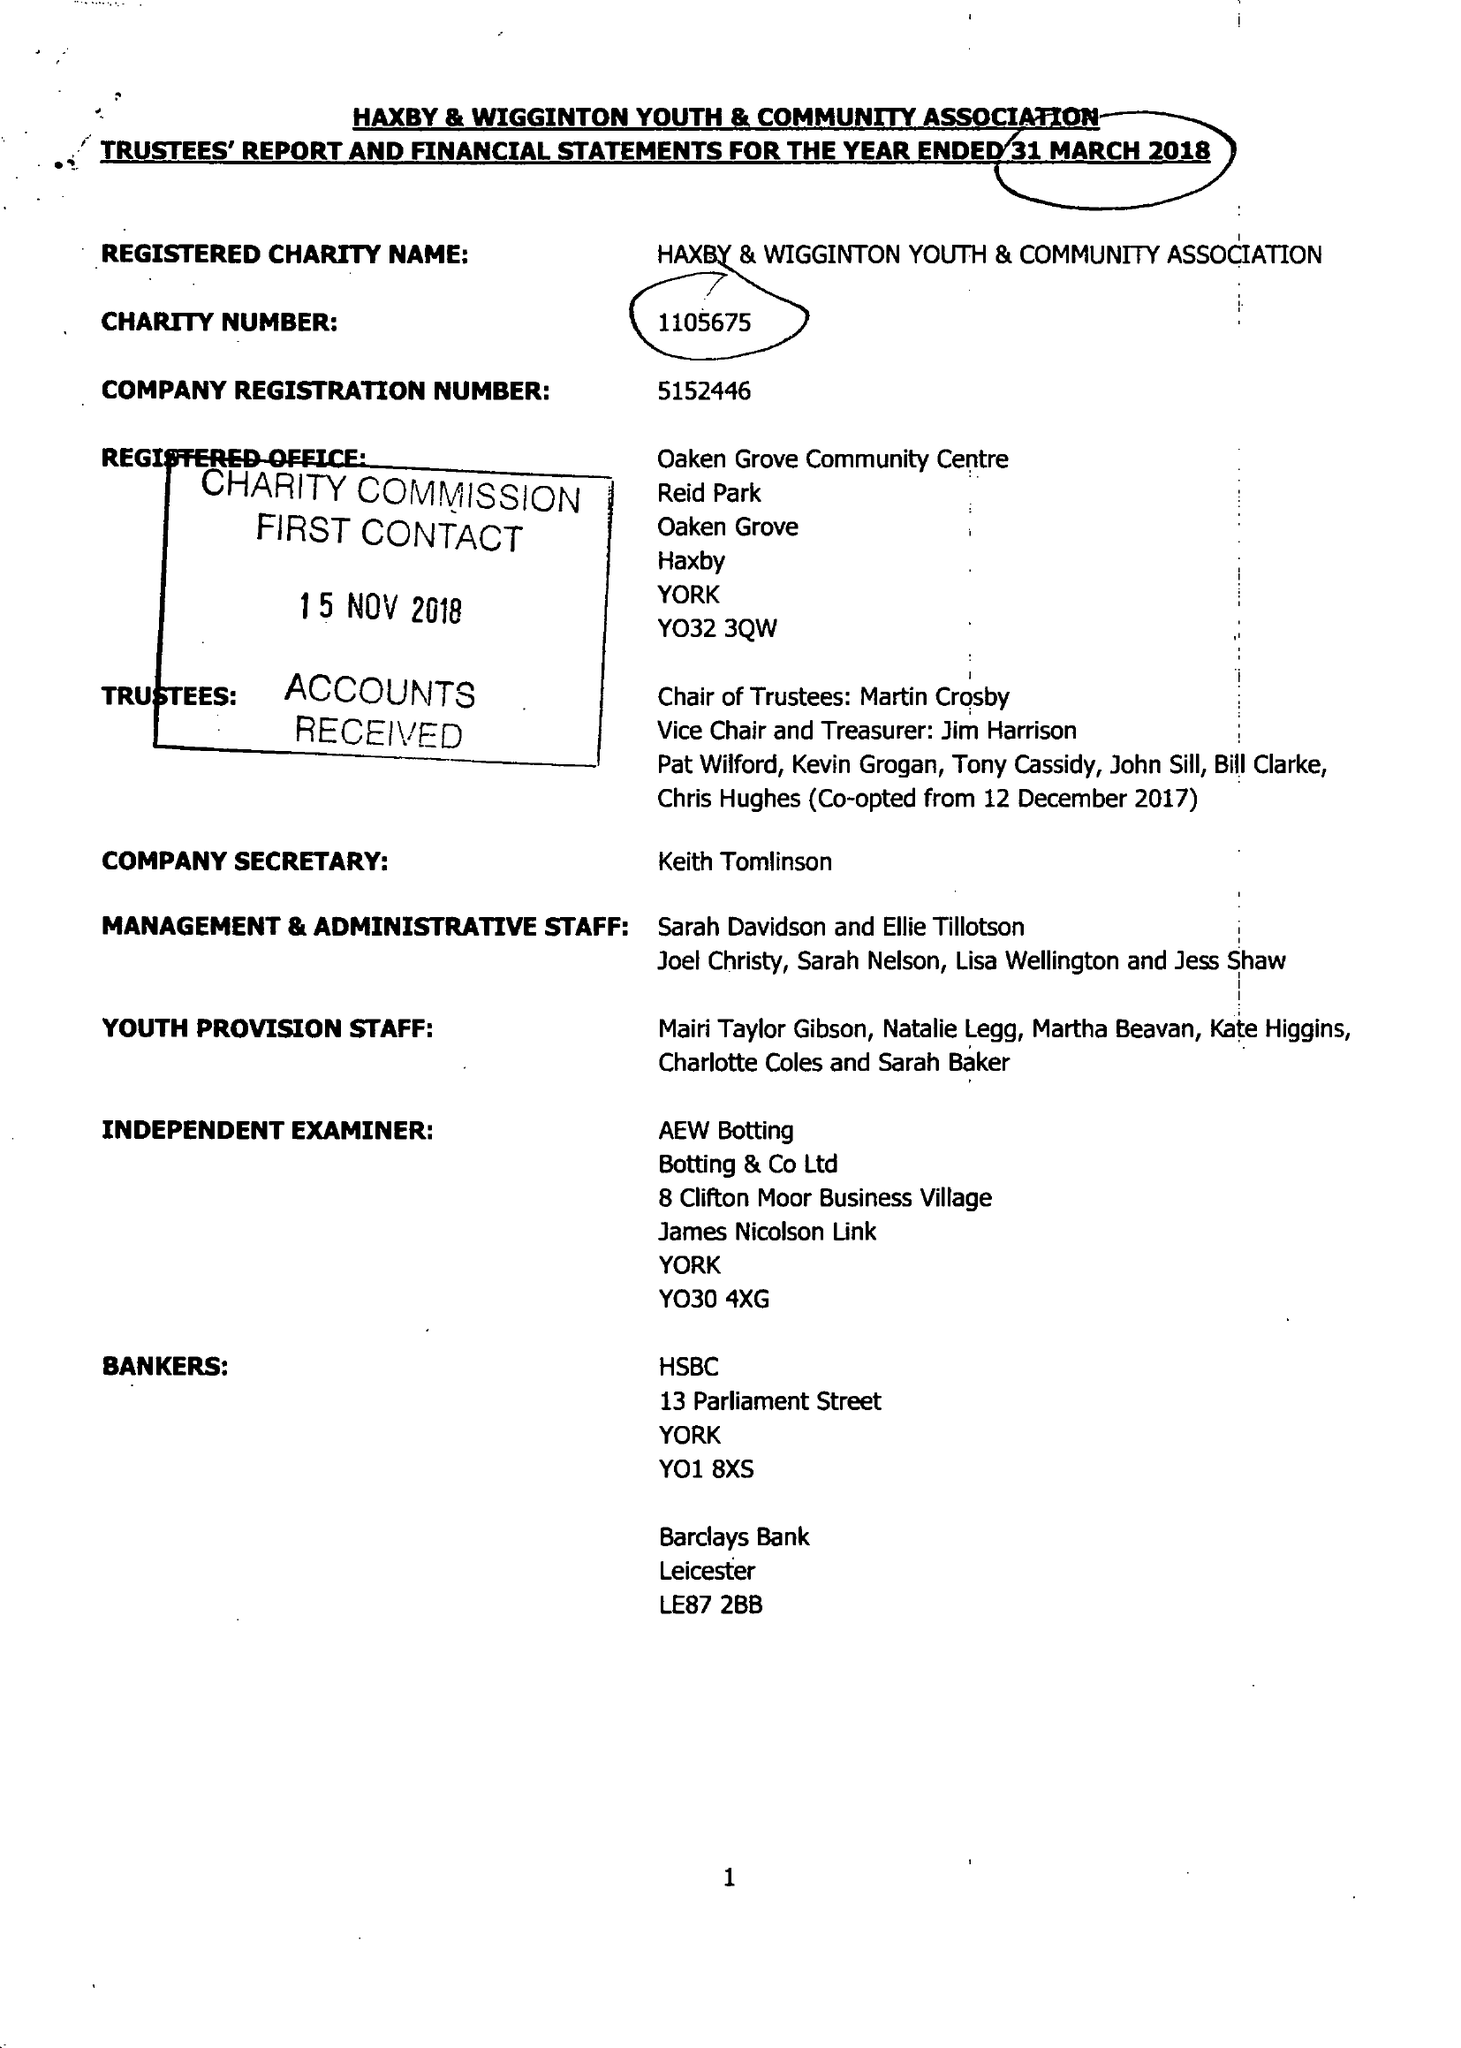What is the value for the address__post_town?
Answer the question using a single word or phrase. None 